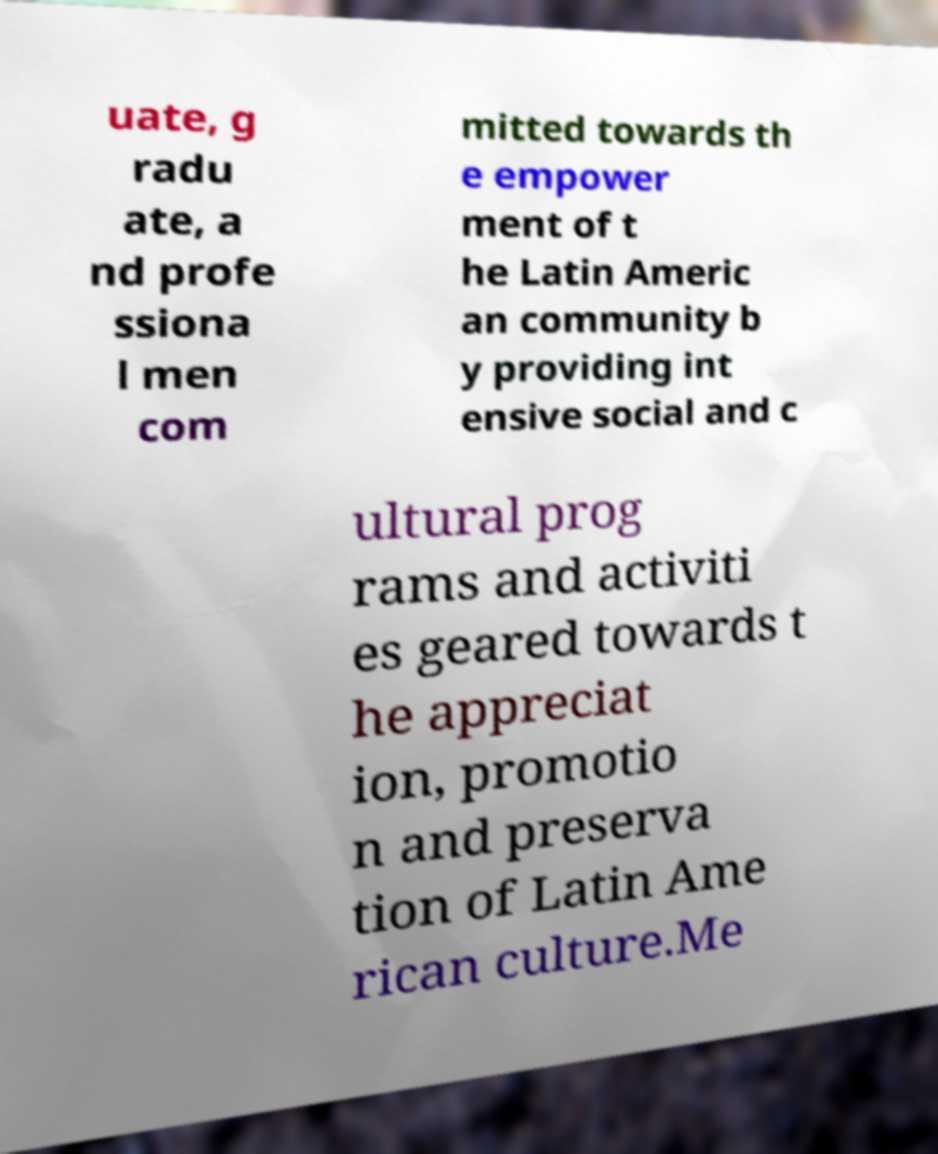I need the written content from this picture converted into text. Can you do that? uate, g radu ate, a nd profe ssiona l men com mitted towards th e empower ment of t he Latin Americ an community b y providing int ensive social and c ultural prog rams and activiti es geared towards t he appreciat ion, promotio n and preserva tion of Latin Ame rican culture.Me 